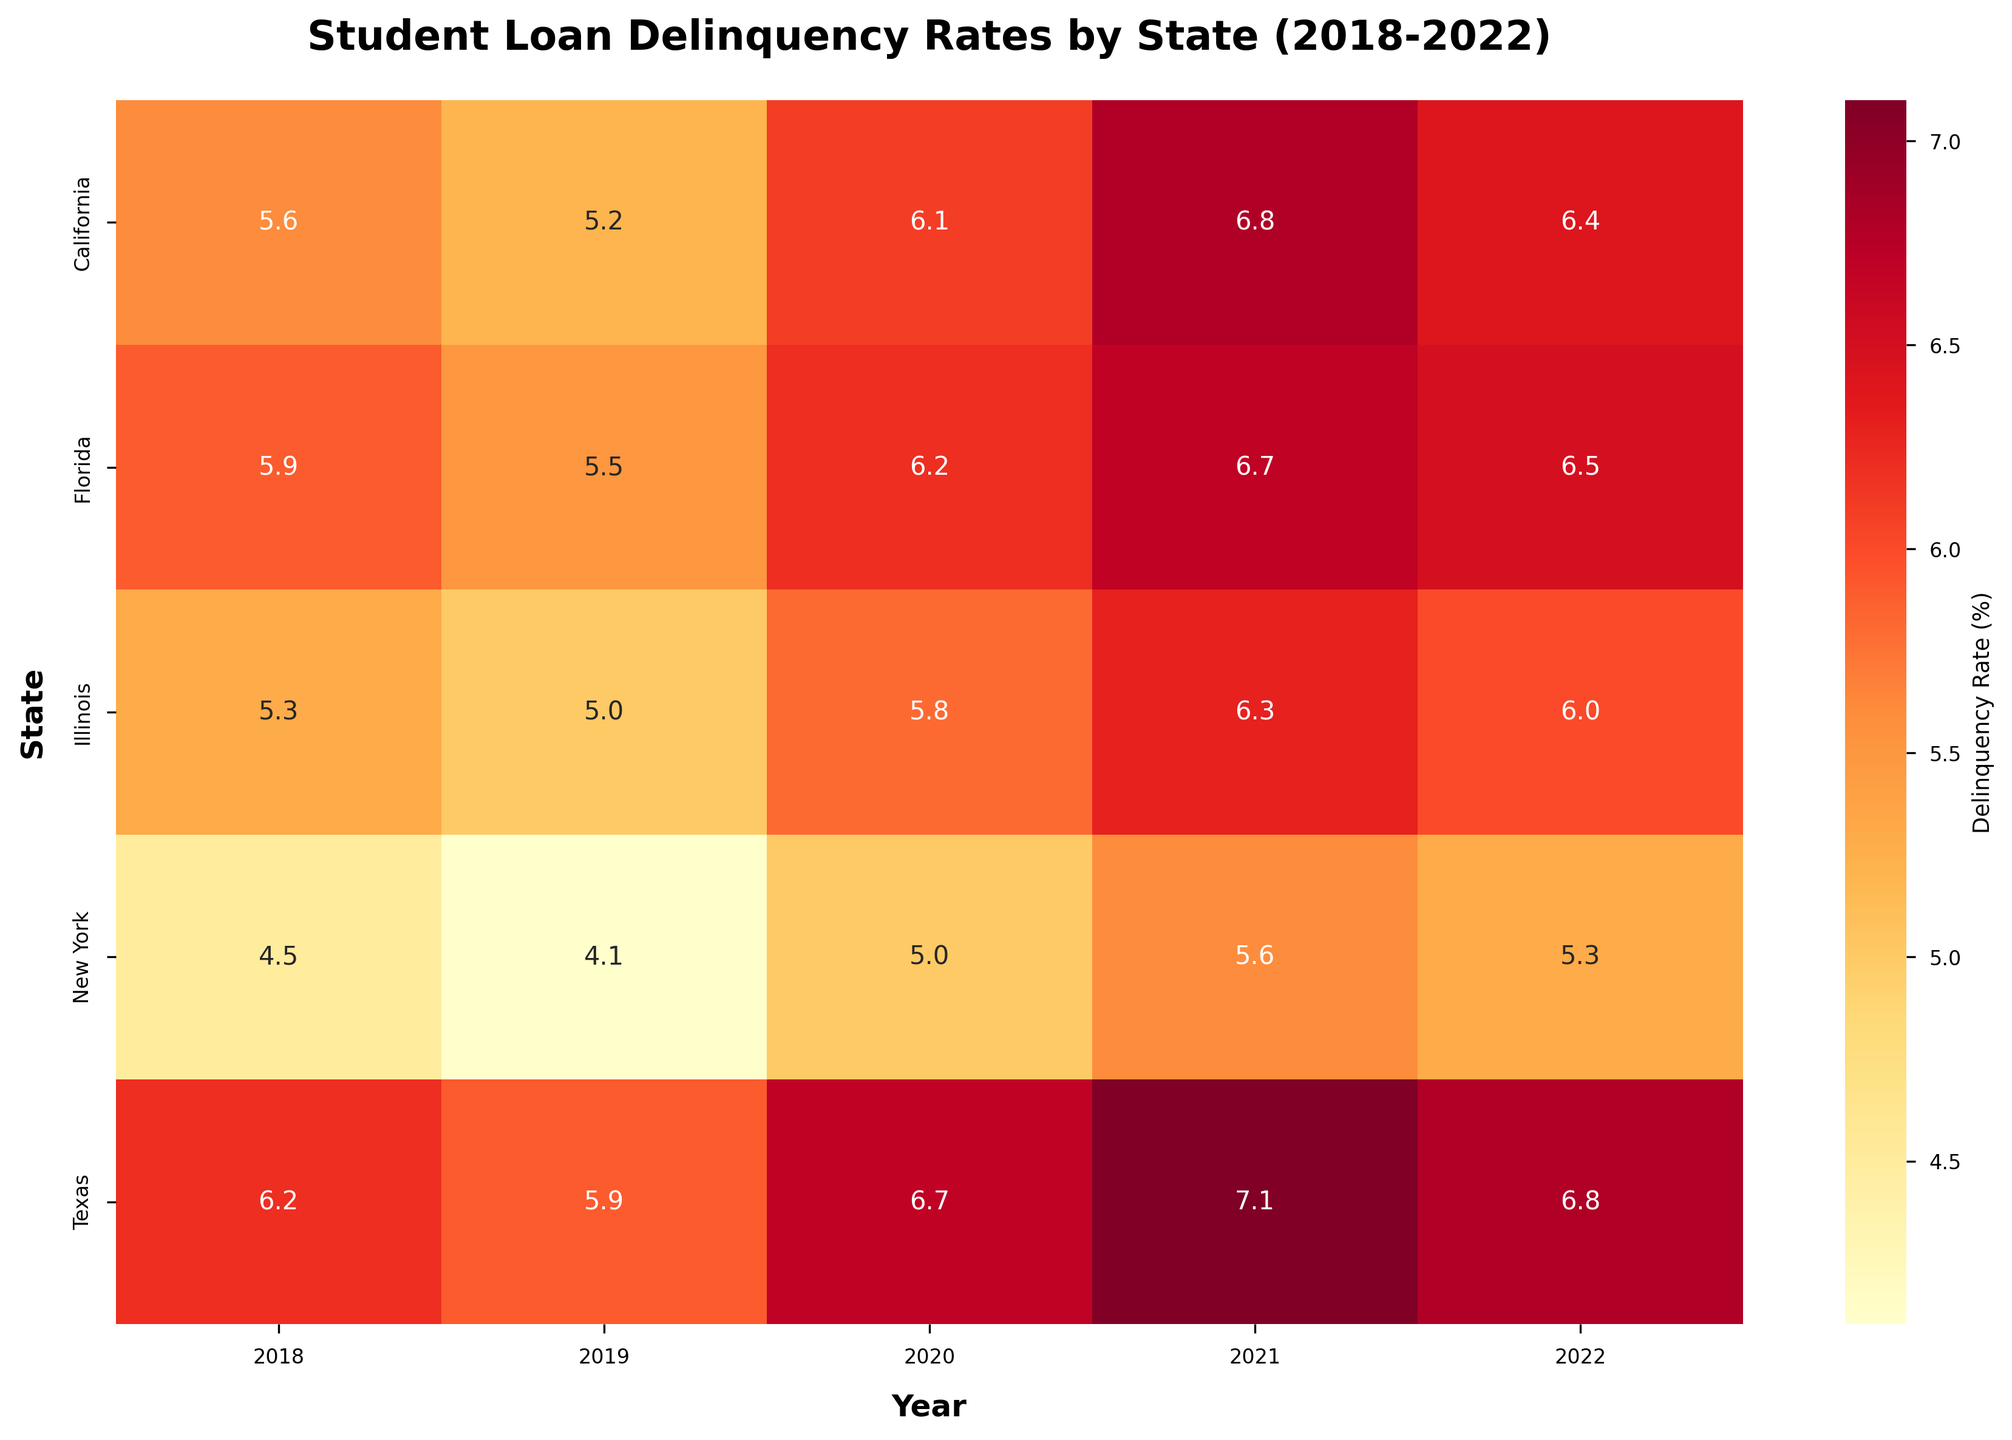What is the title of the heatmap? The title is located at the top of the heatmap, above the actual plot area.
Answer: Student Loan Delinquency Rates by State (2018-2022) Which state had the highest delinquency rate in 2021? Locate the column for the year 2021, then find the state with the highest value in that column.
Answer: Texas What is the average delinquency rate for California over the five years displayed? Identify the five delinquency rates for California, sum them up and divide by five: (5.6 + 5.2 + 6.1 + 6.8 + 6.4) / 5 = 30.1 / 5.
Answer: 6.02 What is the difference in delinquency rate for Florida between 2019 and 2020? Find the delinquency rates for Florida in 2019 and 2020 and compute the difference: 6.2 - 5.5.
Answer: 0.7 Which year had the highest average delinquency rate across all states? Calculate the average delinquency rate for each year by summing the rates for that year and dividing by the number of states, then compare the results.
Answer: 2021 What was the trend of the delinquency rate in Texas over the five years? Identify and compare the delinquency rates for Texas from 2018 to 2022 to discern a pattern.
Answer: Increasing trend Which state had the lowest delinquency rate in 2019? Locate the column for the year 2019, then find the state with the lowest value in that column.
Answer: New York How many states had a delinquency rate above 6% in 2022? Check the values for each state in the 2022 column and count how many are above 6%.
Answer: Three (California, Texas, and Florida) Which state consistently had the lowest delinquency rates over all five years? Compare the delinquency rates of all states across all five years to determine which state had the lowest rates on average.
Answer: New York By how much did the delinquency rate in Illinois increase from 2018 to 2021? Find the delinquency rates for Illinois in 2018 and 2021 and compute the difference: 6.3 - 5.3.
Answer: 1.0 